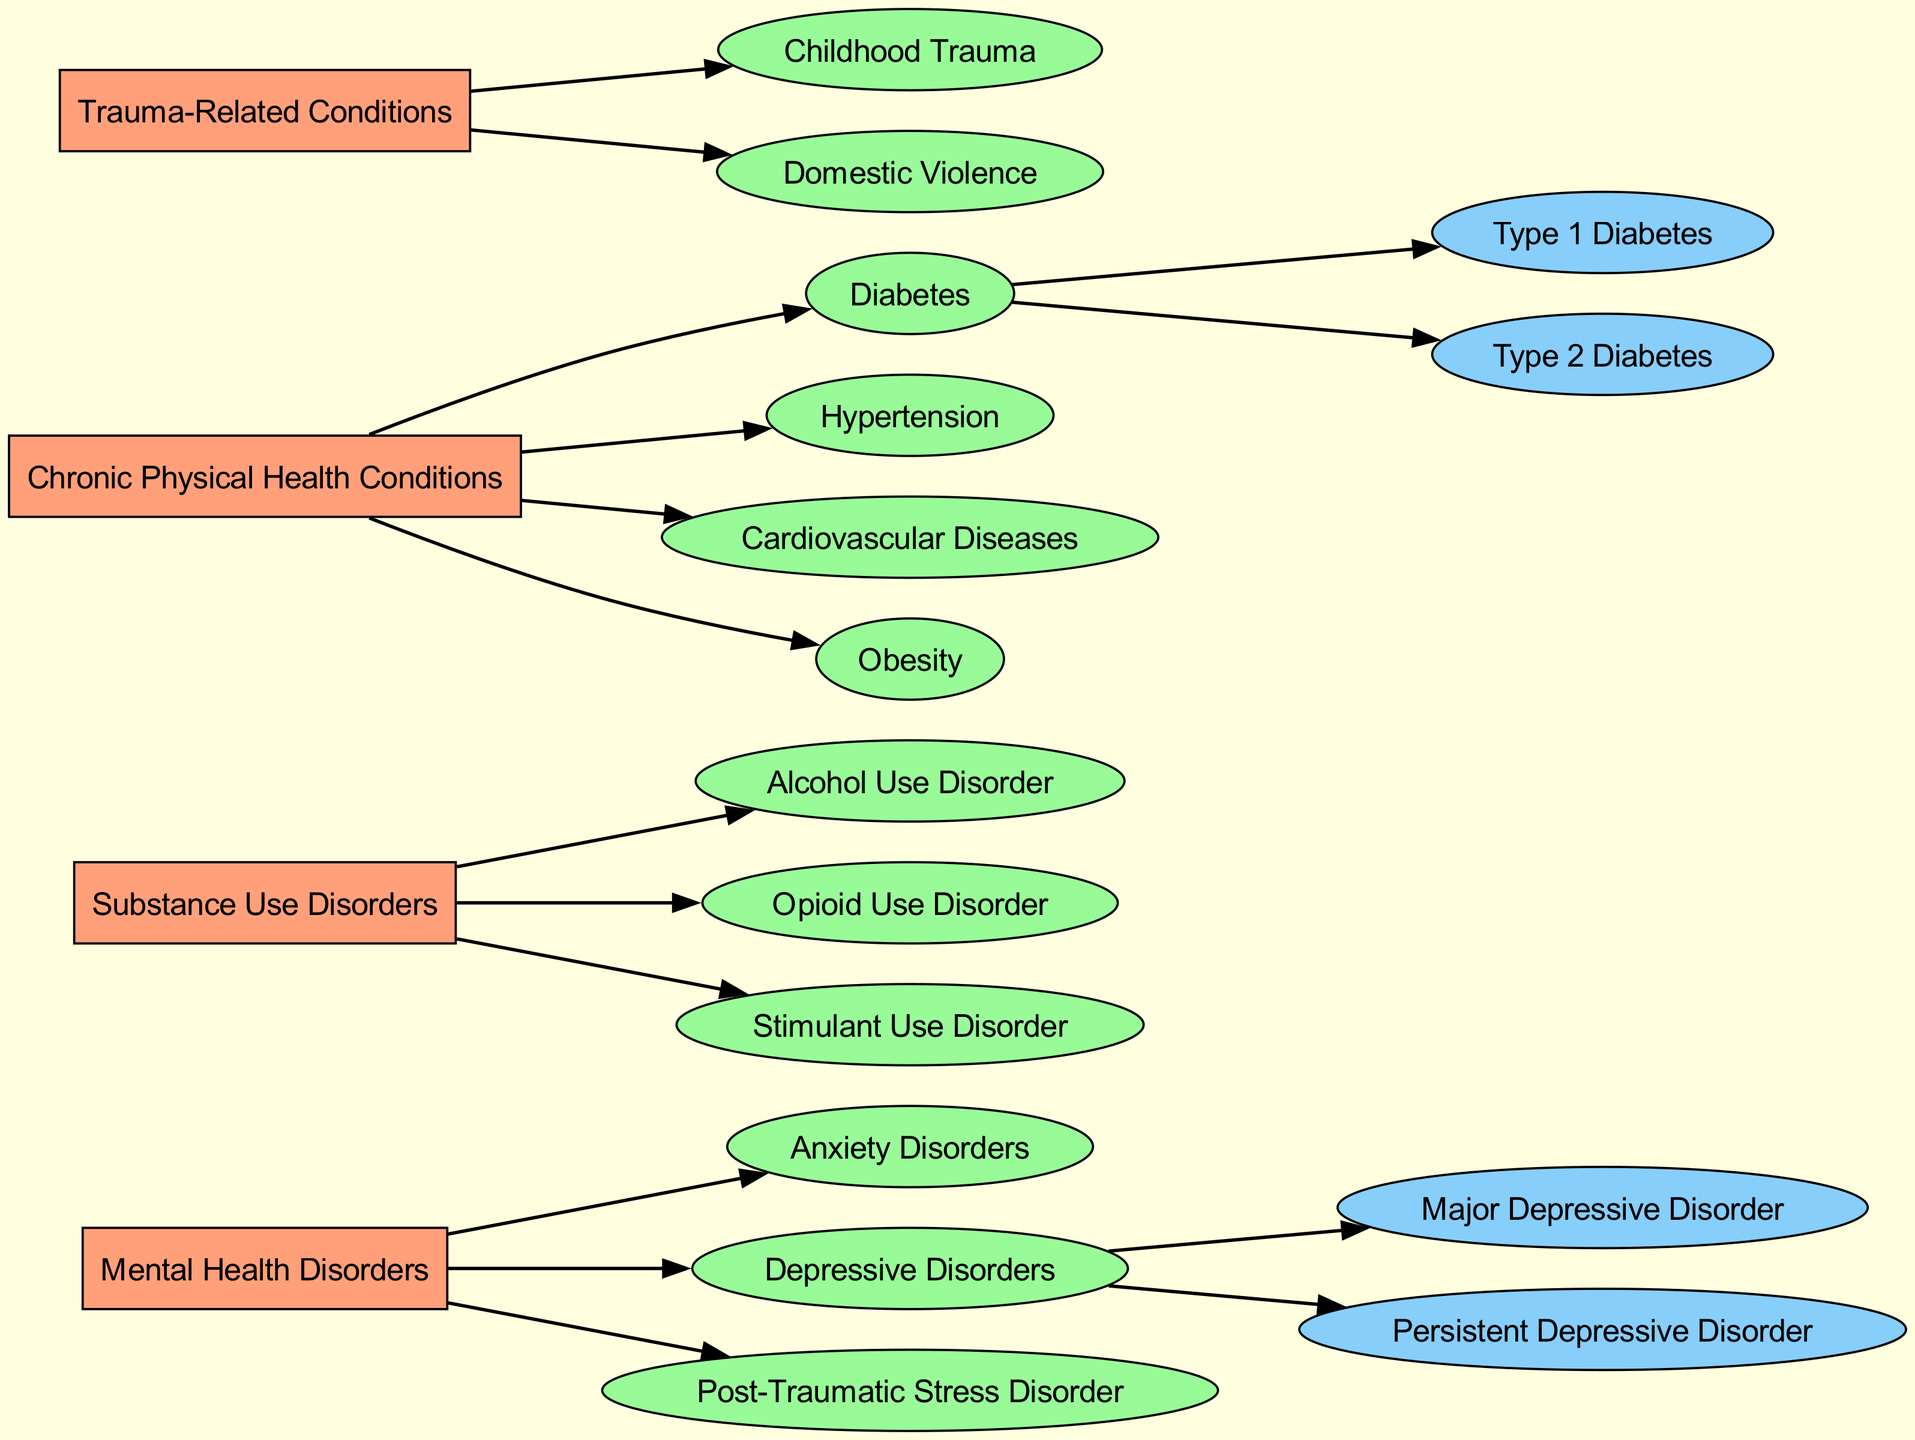What are the main categories of comorbidities? The main categories of comorbidities shown in the diagram are Mental Health Disorders, Substance Use Disorders, Chronic Physical Health Conditions, and Trauma-Related Conditions. These are located at the top level of the decision tree.
Answer: Mental Health Disorders, Substance Use Disorders, Chronic Physical Health Conditions, Trauma-Related Conditions How many types of Anxiety Disorders are listed? The diagram shows that there are no subcategories listed under Anxiety Disorders, which indicates there are zero specified types in the diagram.
Answer: 0 What is a subcategory of Depressive Disorders? The diagram specifies Major Depressive Disorder and Persistent Depressive Disorder as subcategories under Depressive Disorders. Both are detailed as separate entities under the main category.
Answer: Major Depressive Disorder, Persistent Depressive Disorder Which chronic physical health condition includes types? According to the diagram, Diabetes is the only chronic physical health condition that includes subcategories: Type 1 Diabetes and Type 2 Diabetes. This indicates that it has subtypes specified.
Answer: Diabetes What is the total number of substance use disorders listed? The diagram identifies three specific substance use disorders: Alcohol Use Disorder, Opioid Use Disorder, and Stimulant Use Disorder, hence the total number is calculated by counting these individual entries.
Answer: 3 Which condition is categorized under Trauma-Related Conditions? The diagram lists Childhood Trauma and Domestic Violence as the specific conditions that fall under the Trauma-Related Conditions category, making them explicitly identifiable in the tree structure.
Answer: Childhood Trauma, Domestic Violence How many types of Diabetes are mentioned? The diagram specifically lists two types of Diabetes: Type 1 Diabetes and Type 2 Diabetes. Hence, we count these entries to find the total mentioned in the tree.
Answer: 2 Which category includes Post-Traumatic Stress Disorder? The diagram places Post-Traumatic Stress Disorder under the Mental Health Disorders category, illustrating its classification within that main group.
Answer: Mental Health Disorders 